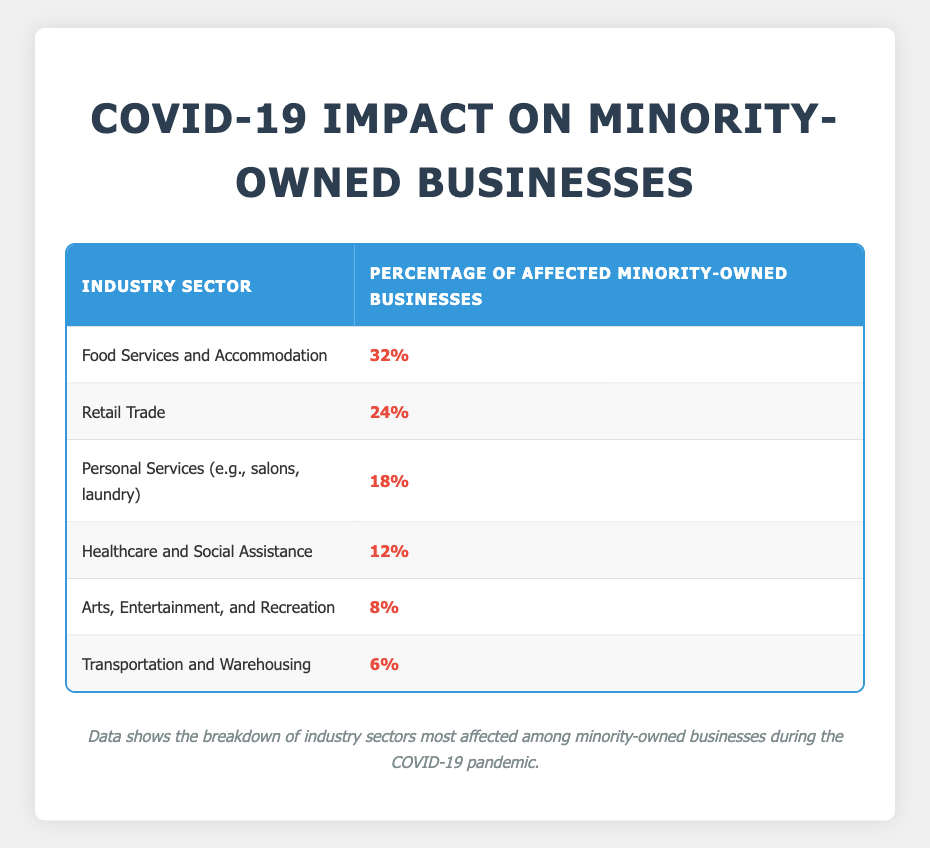What is the industry sector with the highest percentage of affected minority-owned businesses? The table shows various industry sectors and their respective percentages of affected minority-owned businesses. The sector with the highest percentage is listed first, which is Food Services and Accommodation at 32%.
Answer: Food Services and Accommodation What percentage of affected minority-owned businesses does the Retail Trade sector represent? The Retail Trade sector is listed in the second row of the table, which shows that 24% of minority-owned businesses in this sector have been affected.
Answer: 24% Which industry sector reports the lowest percentage of affected minority-owned businesses? By examining the table, the last row contains the Transportation and Warehousing sector, which has the lowest reported percentage of affected minority-owned businesses at 6%.
Answer: Transportation and Warehousing What is the combined percentage of affected minority-owned businesses in the Food Services and Personal Services sectors? To find the combined percentage, add the percentages of affected minority-owned businesses in the Food Services (32%) and Personal Services (18%) sectors together: 32% + 18% = 50%.
Answer: 50% True or False: The Healthcare and Social Assistance sector has a higher percentage of affected minority-owned businesses than the Arts, Entertainment, and Recreation sector. To answer this, compare the percentages: Healthcare and Social Assistance has 12%, while Arts, Entertainment, and Recreation has 8%. Since 12% is greater than 8%, the statement is true.
Answer: True Which two industry sectors combined represent more than 40% of the affected minority-owned businesses? The Food Services sector (32%) combined with the Retail Trade sector (24%) total to 56%, which is more than 40%. Alternatively, Food Services (32%) and Personal Services (18%) also total 50%, exceeding 40%.
Answer: Food Services and Retail Trade, or Food Services and Personal Services How many industry sectors have less than 10% of affected minority-owned businesses? Checking the table, only the Transportation and Warehousing sector (6%) and the Arts, Entertainment, and Recreation sector (8%) are below 10%. Thus, there are two sectors total.
Answer: 2 What is the average percentage of affected minority-owned businesses across all the sectors listed? To calculate the average, sum up all the percentages: 32% + 24% + 18% + 12% + 8% + 6% = 100%. Then divide by the number of industries, which is 6. Therefore, the average is 100% / 6 = 16.67%.
Answer: 16.67% 